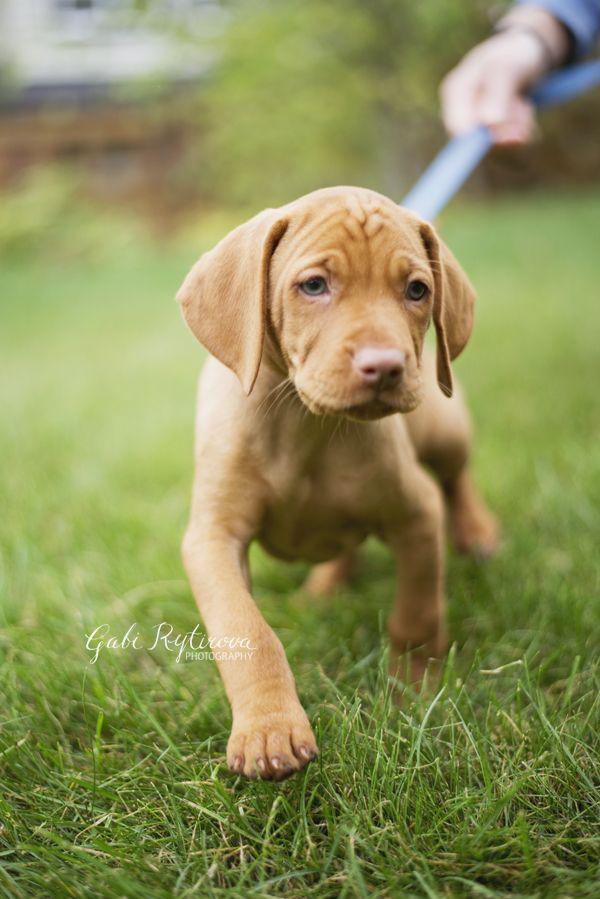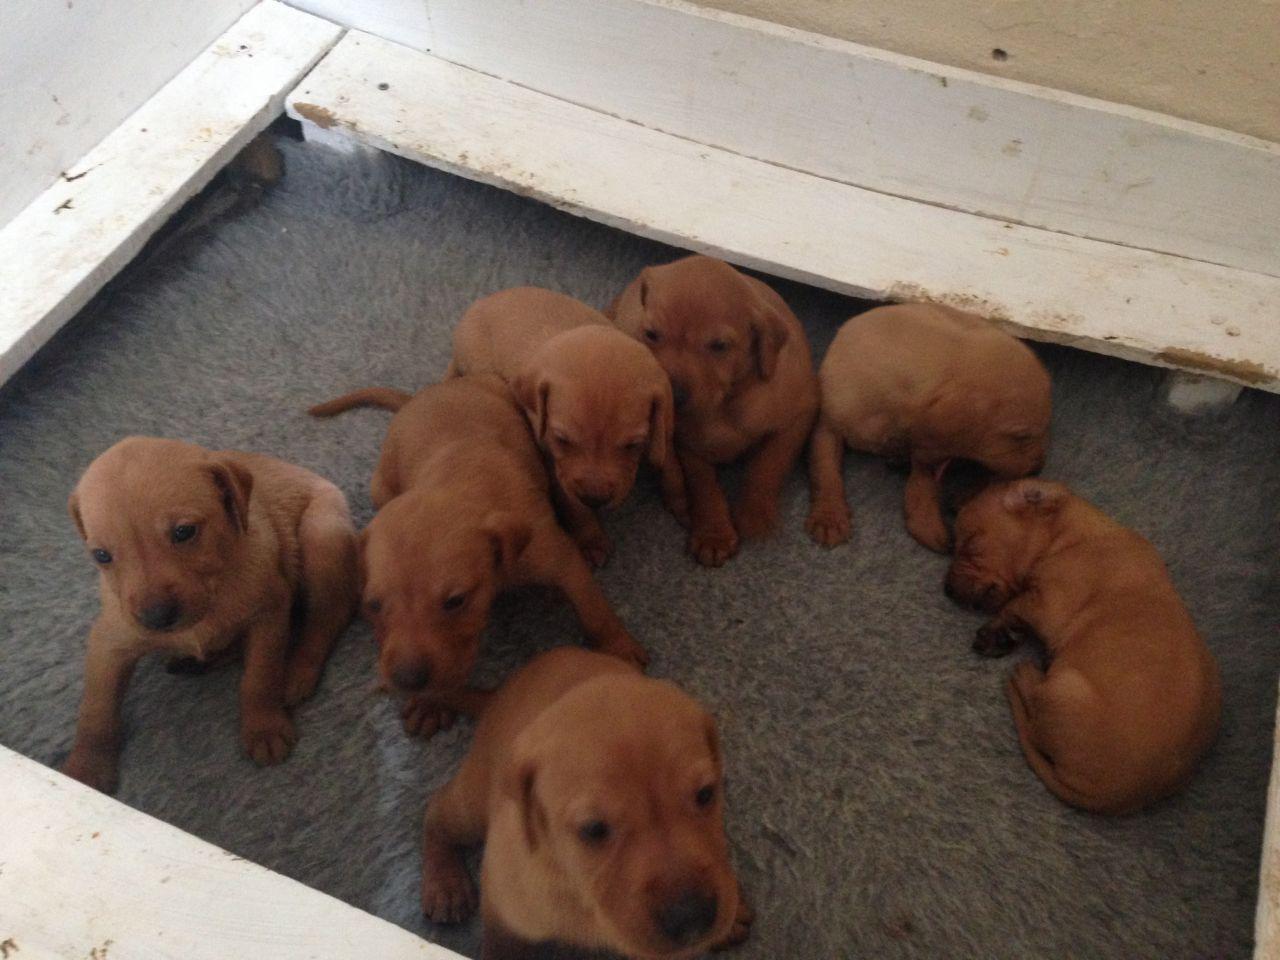The first image is the image on the left, the second image is the image on the right. For the images displayed, is the sentence "There are at most 5 dogs in total." factually correct? Answer yes or no. No. 